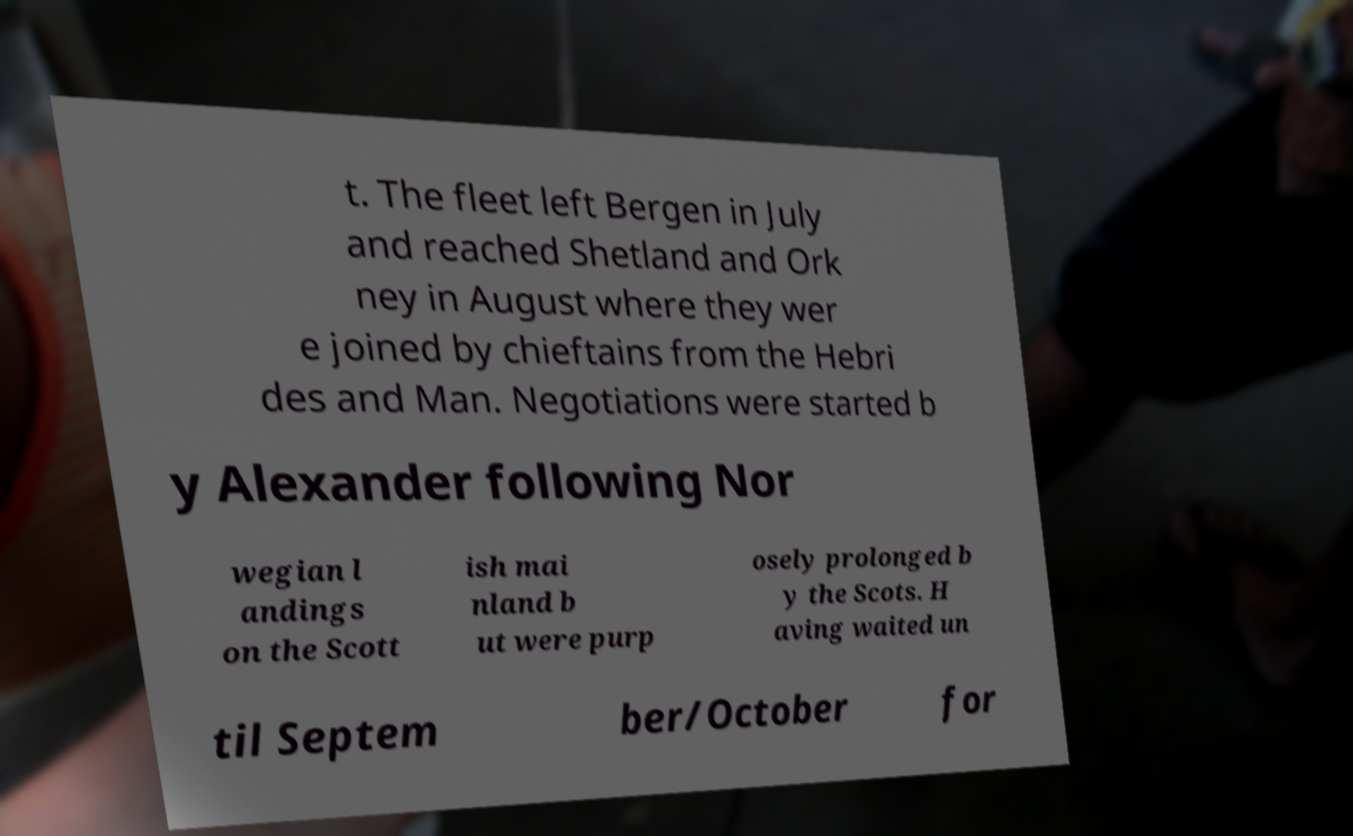What messages or text are displayed in this image? I need them in a readable, typed format. t. The fleet left Bergen in July and reached Shetland and Ork ney in August where they wer e joined by chieftains from the Hebri des and Man. Negotiations were started b y Alexander following Nor wegian l andings on the Scott ish mai nland b ut were purp osely prolonged b y the Scots. H aving waited un til Septem ber/October for 